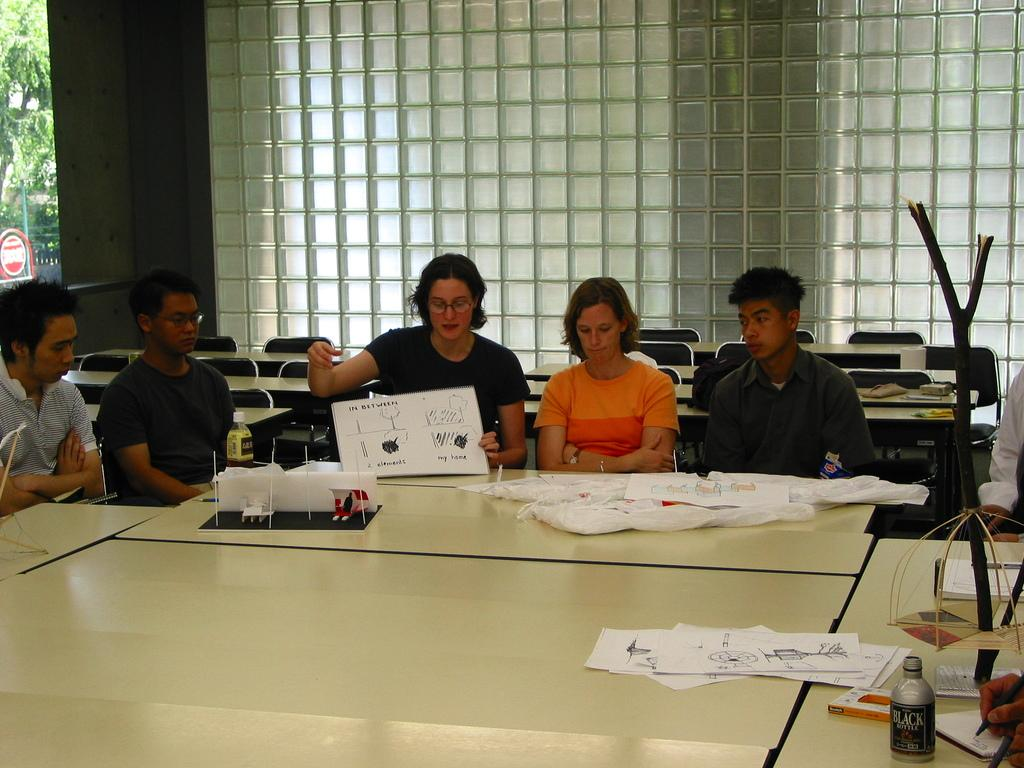What are the people in the image doing? The people in the image are sitting on chairs. What is the main piece of furniture in the image? There is a table in the image. What is on the table? There is a poster, papers, a bottle, and covers on the table. What type of print can be seen on the horn in the image? There is no horn present in the image. How many chickens are visible on the table in the image? There are no chickens present in the image. 